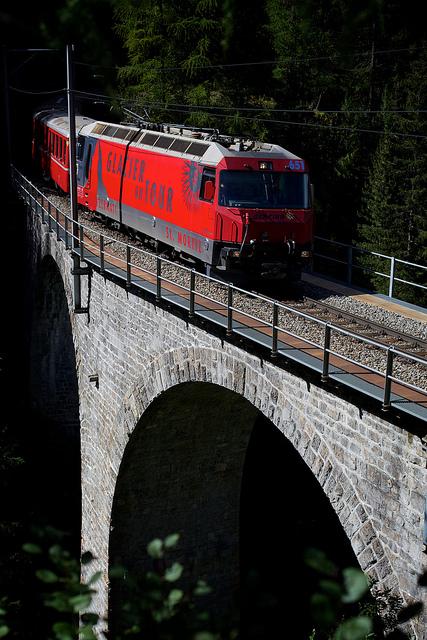Is there graffiti on the bridge?
Answer briefly. No. What does it say on the side of the train?
Give a very brief answer. Glacier tour. Is the train on the ground?
Give a very brief answer. No. What geological feature is the train traversing over?
Give a very brief answer. Bridge. What bridge is that?
Quick response, please. Train bridge. 